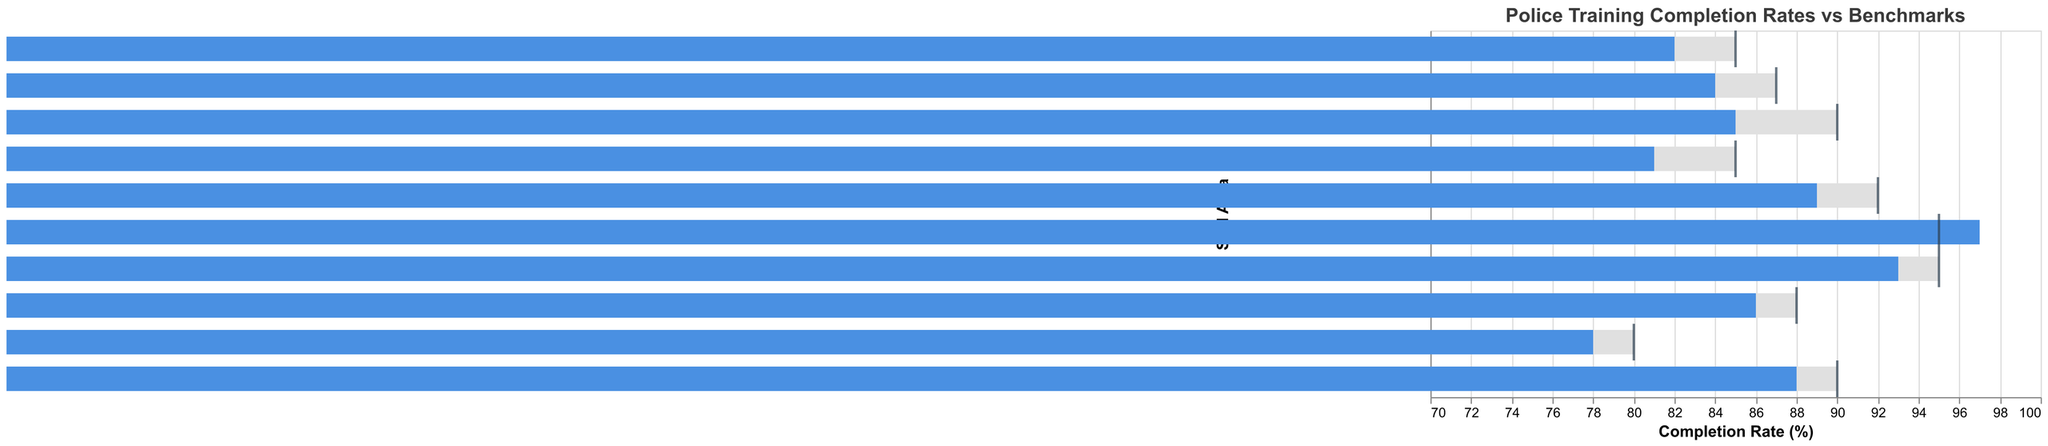What's the title of the figure? The title of the figure can be found at the top of the chart. It reads "Police Training Completion Rates vs Benchmarks."
Answer: Police Training Completion Rates vs Benchmarks How many skill areas are shown in the chart? The number of skill areas can be determined by counting the distinct categories on the y-axis of the chart. There are 10 skill areas listed.
Answer: 10 Which skill area exceeds its benchmark the most? By comparing the Actual Completion Rate and Benchmark for each skill area, it's evident that "Firearms Proficiency" (97% vs 95%) exceeds its benchmark by the biggest margin.
Answer: Firearms Proficiency Which skill area has the lowest Actual Completion Rate? By scanning the Actual Completion Rate bars, the "Physical Fitness" skill area has the lowest Actual Completion Rate of 78%.
Answer: Physical Fitness What is the difference between the benchmark and actual completion rate for Emergency Response? Subtract the Actual Completion Rate (89%) from the Benchmark (92%) for Emergency Response. The difference is 92% - 89% = 3%.
Answer: 3% Which skill areas did not meet their benchmarks? Compare Actual Completion Rate with Benchmark for each skill area. The skill areas that did not meet their benchmarks are "De-escalation Techniques," "Community Policing," "Emergency Response," "Legal Knowledge," "Physical Fitness," "Crisis Intervention," and "Diversity and Inclusion Training."
Answer: De-escalation Techniques, Community Policing, Emergency Response, Legal Knowledge, Physical Fitness, Crisis Intervention, Diversity and Inclusion Training How many skill areas have a benchmark of 90% or above? Count the number of skill areas whose Benchmark is 90% or higher. The qualifying skill areas are "De-escalation Techniques," "Firearms Proficiency," "Report Writing," and "First Aid and CPR," totaling 4 skill areas.
Answer: 4 Which skill areas fall short of their benchmarks by less than 5%? Identify skill areas where the difference between Benchmark and Actual Completion Rate is less than 5%. These are "Emergency Response" (3%), "Legal Knowledge" (2%), "Report Writing" (2%), and "First Aid and CPR" (2%).
Answer: Emergency Response, Legal Knowledge, Report Writing, First Aid and CPR What is the average benchmark for all skill areas? Add the benchmarks for all skill areas and divide by the number of skill areas. Calculating: (90+95+85+92+88+80+87+85+90+95)/10 = 88.7%.
Answer: 88.7% 